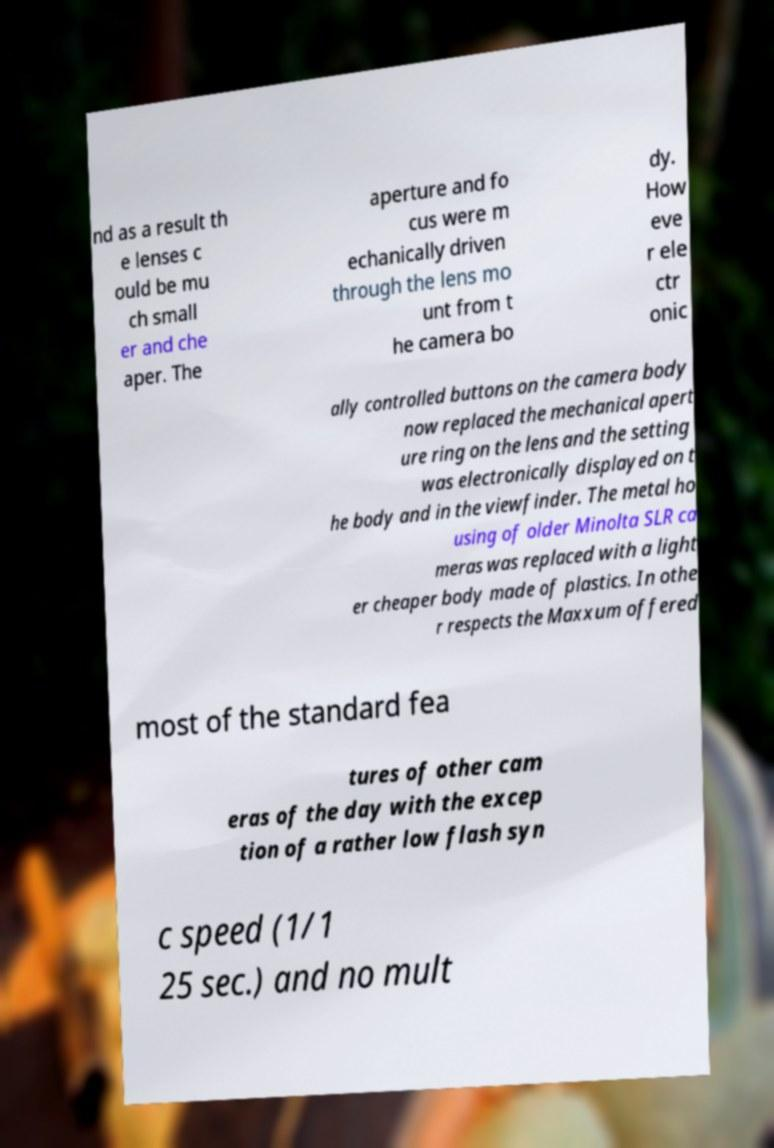Can you read and provide the text displayed in the image?This photo seems to have some interesting text. Can you extract and type it out for me? nd as a result th e lenses c ould be mu ch small er and che aper. The aperture and fo cus were m echanically driven through the lens mo unt from t he camera bo dy. How eve r ele ctr onic ally controlled buttons on the camera body now replaced the mechanical apert ure ring on the lens and the setting was electronically displayed on t he body and in the viewfinder. The metal ho using of older Minolta SLR ca meras was replaced with a light er cheaper body made of plastics. In othe r respects the Maxxum offered most of the standard fea tures of other cam eras of the day with the excep tion of a rather low flash syn c speed (1/1 25 sec.) and no mult 